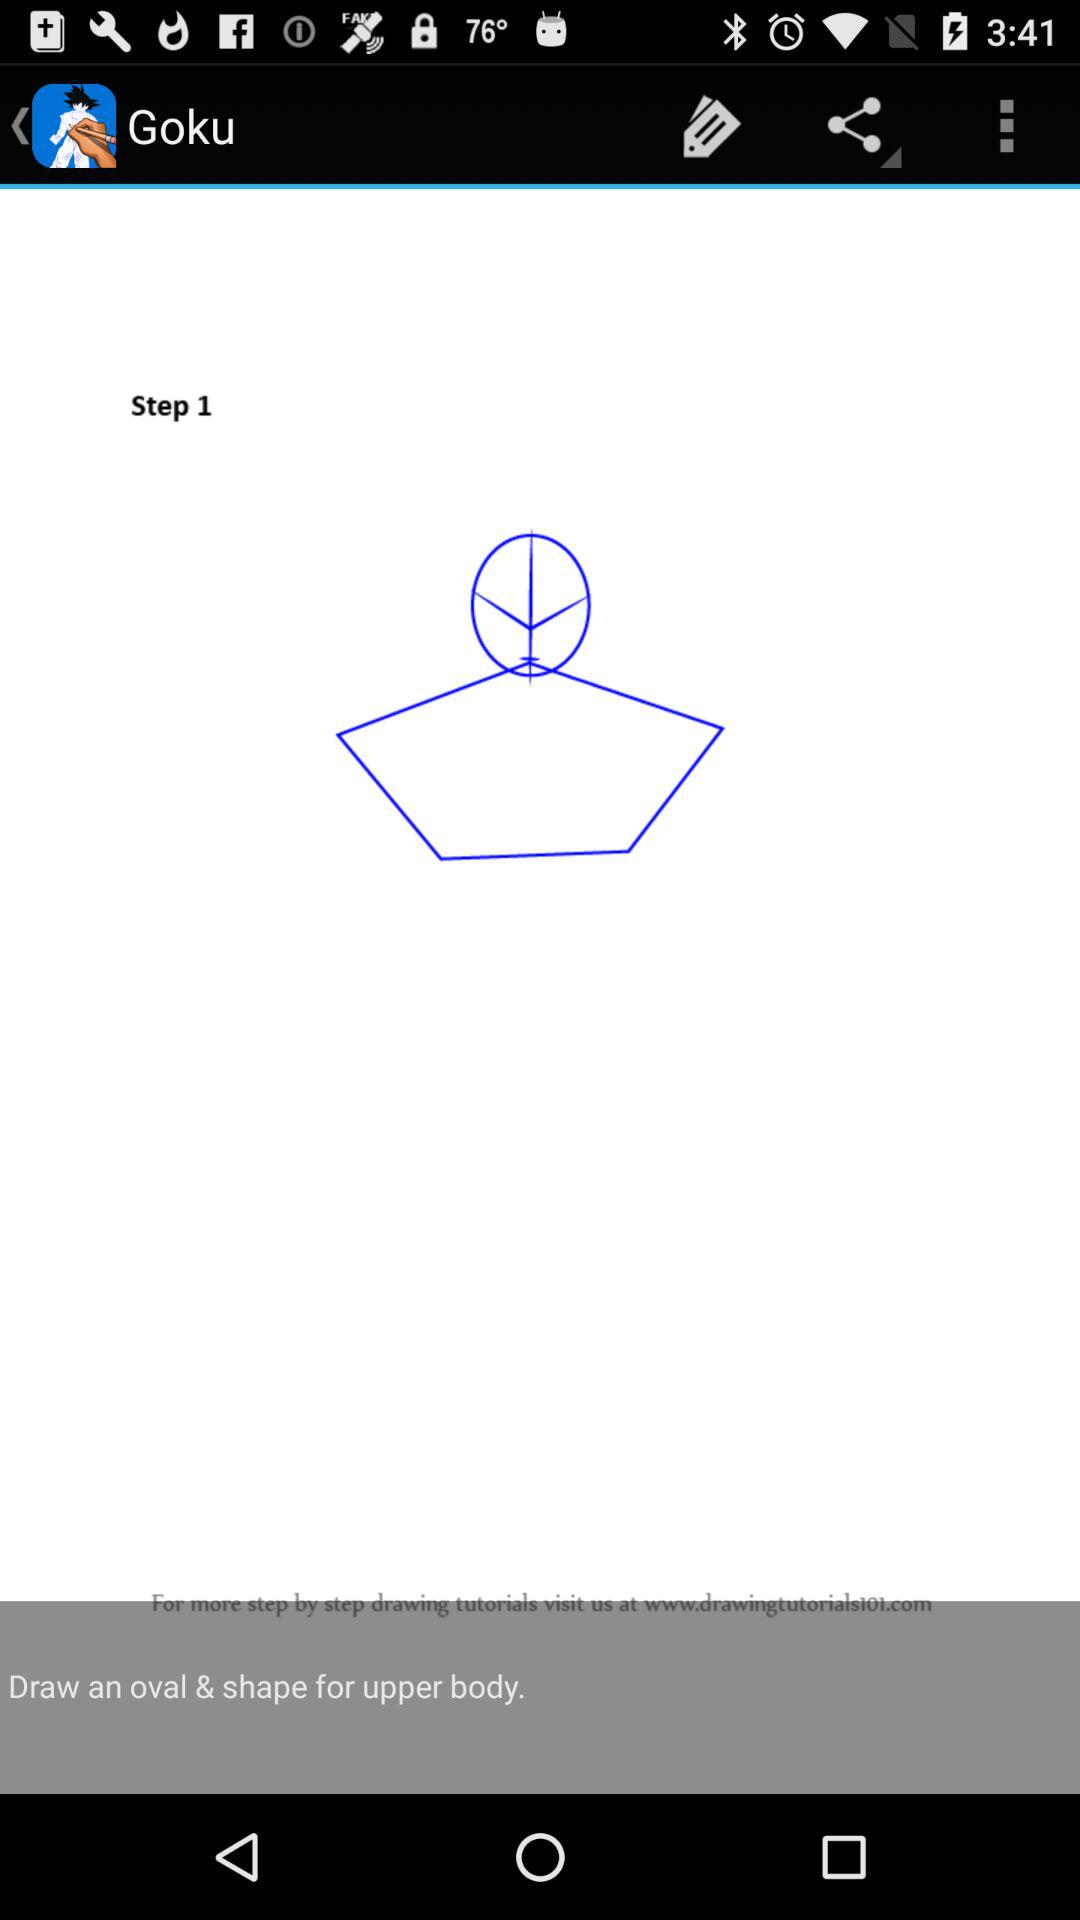What is the name of the application? The name of the application is "Goku". 